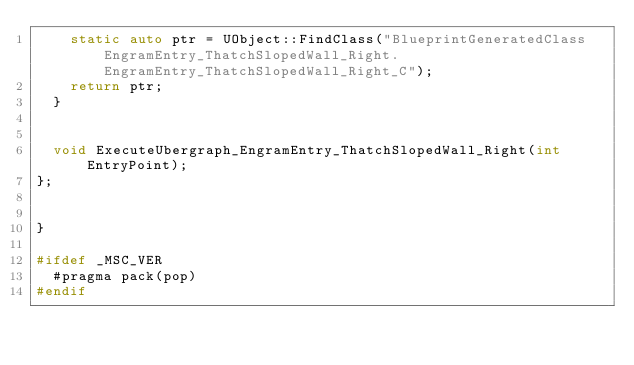Convert code to text. <code><loc_0><loc_0><loc_500><loc_500><_C++_>		static auto ptr = UObject::FindClass("BlueprintGeneratedClass EngramEntry_ThatchSlopedWall_Right.EngramEntry_ThatchSlopedWall_Right_C");
		return ptr;
	}


	void ExecuteUbergraph_EngramEntry_ThatchSlopedWall_Right(int EntryPoint);
};


}

#ifdef _MSC_VER
	#pragma pack(pop)
#endif
</code> 